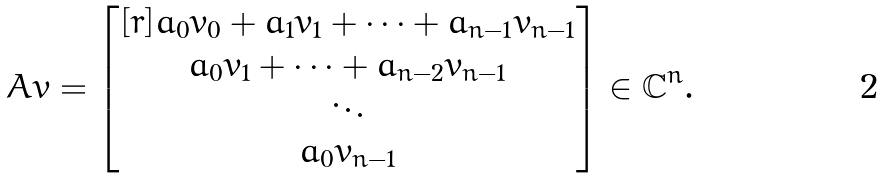Convert formula to latex. <formula><loc_0><loc_0><loc_500><loc_500>A v = \begin{bmatrix} [ r ] a _ { 0 } v _ { 0 } + a _ { 1 } v _ { 1 } + \cdots + a _ { n - 1 } v _ { n - 1 } \\ a _ { 0 } v _ { 1 } + \cdots + a _ { n - 2 } v _ { n - 1 } \\ \ddots \\ a _ { 0 } v _ { n - 1 } \end{bmatrix} \in \mathbb { C } ^ { n } .</formula> 